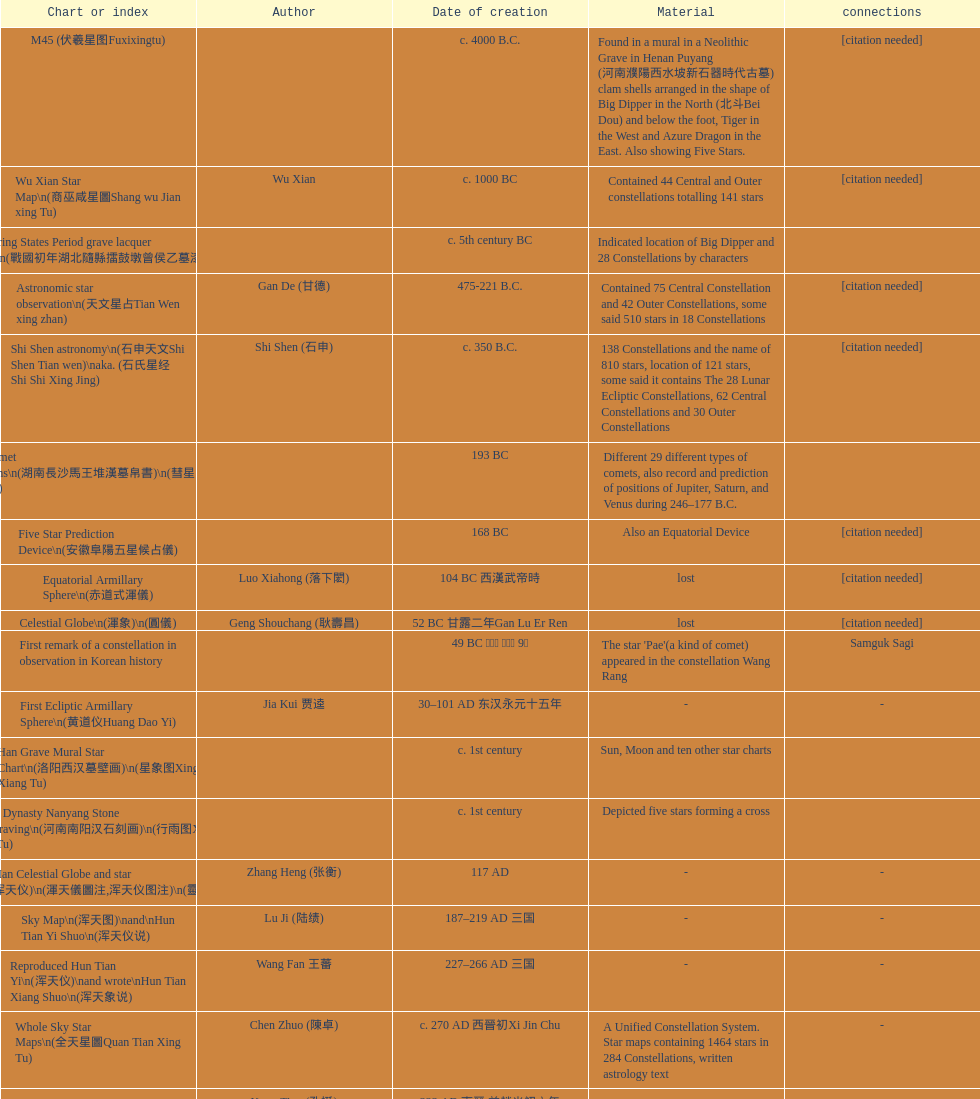Did xu guang ci or su song create the five star charts in 1094 ad? Su Song 蘇頌. 